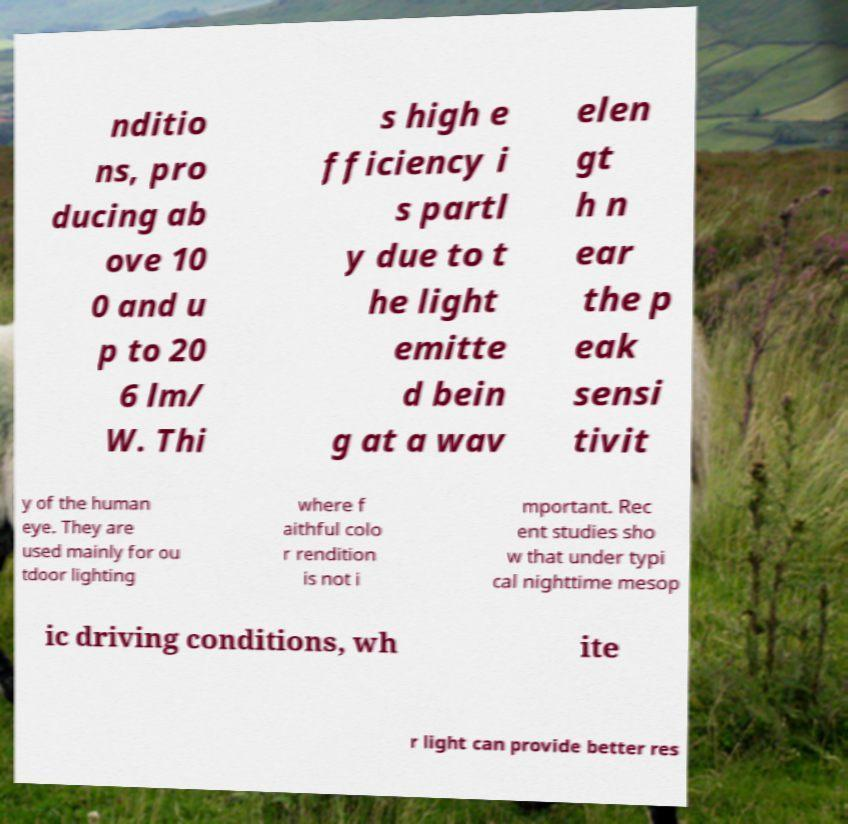Can you accurately transcribe the text from the provided image for me? nditio ns, pro ducing ab ove 10 0 and u p to 20 6 lm/ W. Thi s high e fficiency i s partl y due to t he light emitte d bein g at a wav elen gt h n ear the p eak sensi tivit y of the human eye. They are used mainly for ou tdoor lighting where f aithful colo r rendition is not i mportant. Rec ent studies sho w that under typi cal nighttime mesop ic driving conditions, wh ite r light can provide better res 